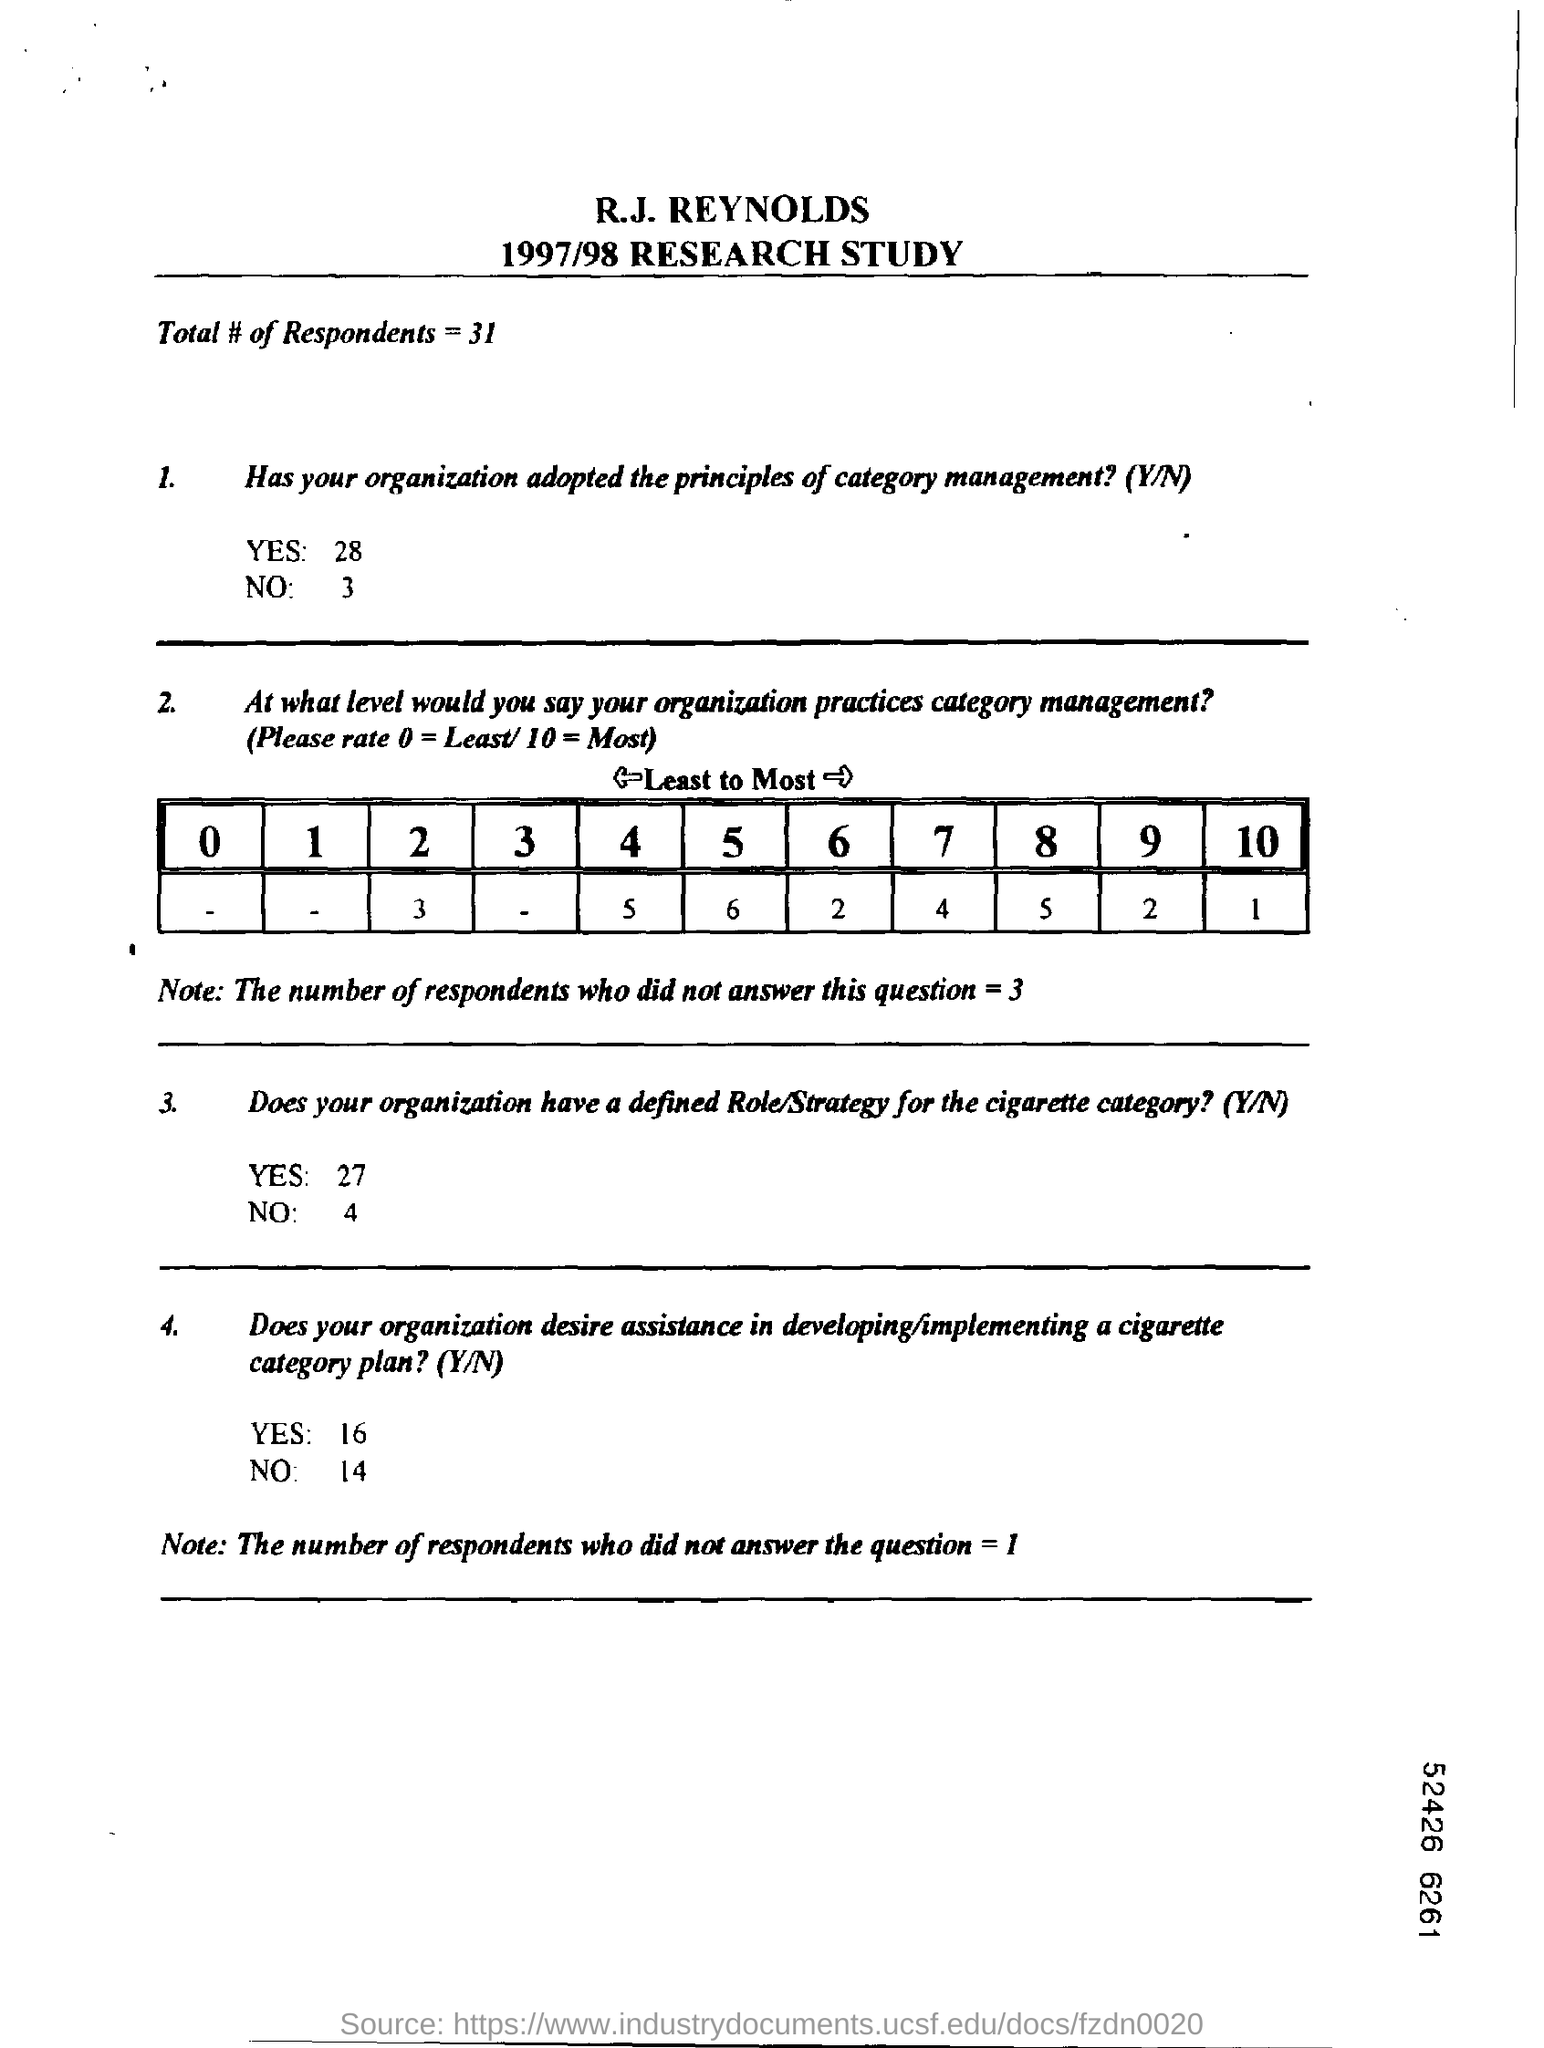What is this document about?
Give a very brief answer. 1997/78 research study. What is the Total # of Respondents?
Keep it short and to the point. 31. 